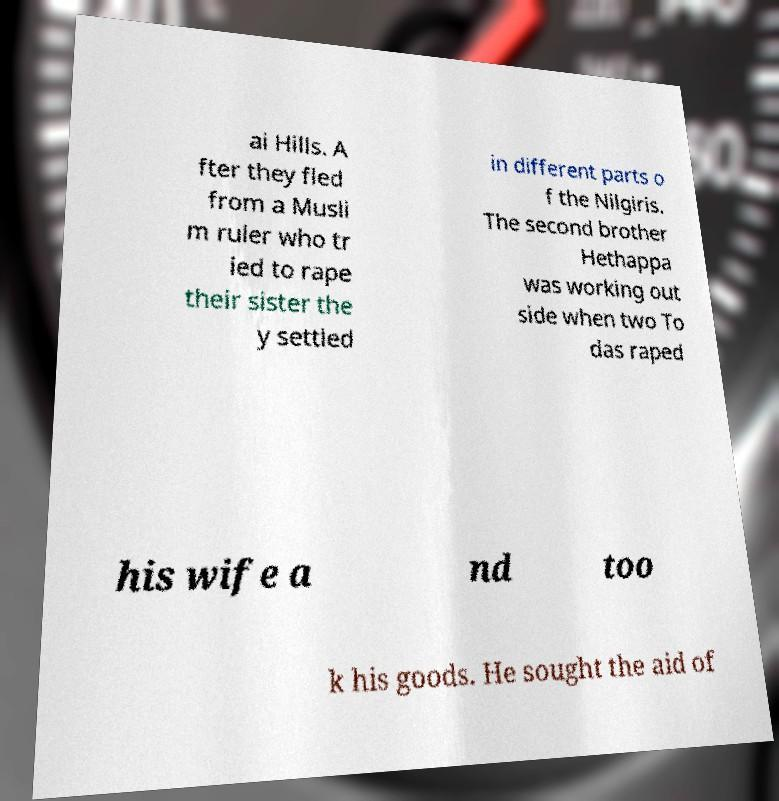Could you assist in decoding the text presented in this image and type it out clearly? ai Hills. A fter they fled from a Musli m ruler who tr ied to rape their sister the y settled in different parts o f the Nilgiris. The second brother Hethappa was working out side when two To das raped his wife a nd too k his goods. He sought the aid of 